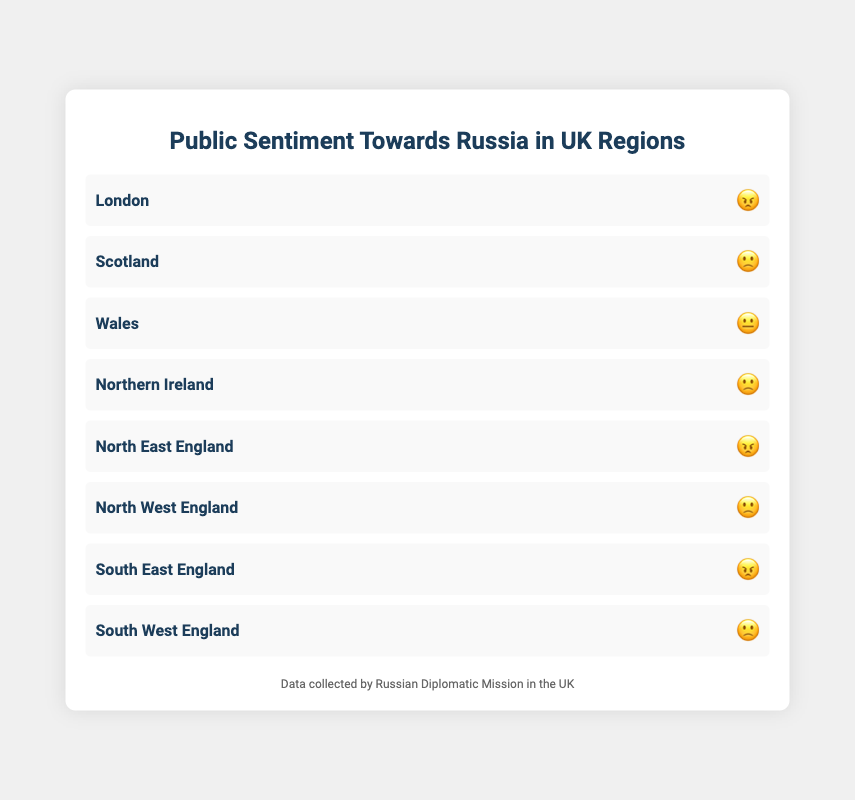Which region has the most negative sentiment towards Russia? The region with the most negative sentiment can be identified by the "😠" emoji. In the chart, "😠" appears next to London, North East England, and South East England. These regions have the most negative sentiment.
Answer: London, North East England, South East England How many regions are represented in the chart? The chart lists the regions, and each region corresponds to one row. By counting the rows, we find there are 8 regions represented.
Answer: 8 Which sentiment is most common across all UK regions in the chart? To determine the most common sentiment, count the frequency of each emoji. The counts are: 😠 (3), 🙁 (4), 😐 (1). The most common sentiment is indicated by "🙁".
Answer: 🙁 Is there any region with a neutral sentiment towards Russia? Neutral sentiment is represented by the “😐” emoji. In the chart, only Wales has the neutral emoji next to its name.
Answer: Wales How does Scotland's sentiment compare to that of Northern Ireland? Check the emoji next to Scotland and Northern Ireland to compare their sentiments. Scotland has "🙁", while Northern Ireland also has "🙁". Both regions have the same sentiment.
Answer: Same What is the total number of regions that show a sentiment worse than neutral towards Russia? Sentiments worse than neutral are represented by "😠" and "🙁". Count the number of regions with these emojis: London, Scotland, Northern Ireland, North East England, North West England, South East England, and South West England. There are 7 regions.
Answer: 7 How many regions have a sentiment better than "🙁" but worse than "😠"? Sentiments better than "😠" but not as good as neutral are represented by "🙁". Count the regions with this emoji: Scotland, Northern Ireland, North West England, South West England. There are 4 regions with this sentiment.
Answer: 4 